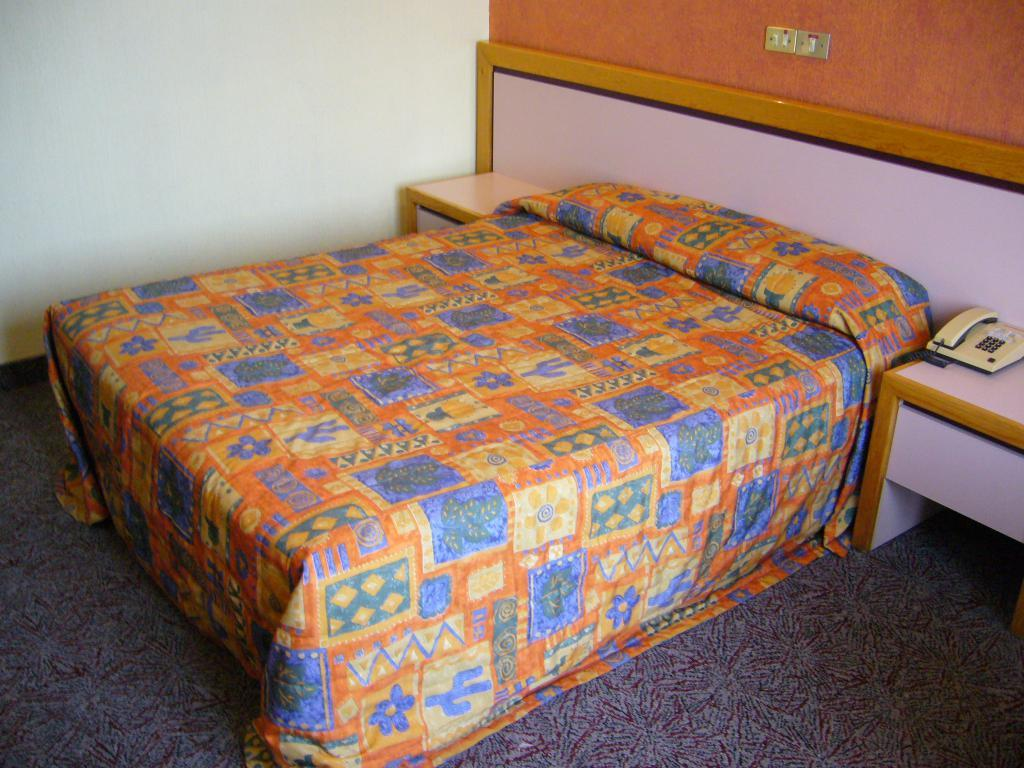What piece of furniture is present in the image? There is a bed in the image. What is covering the bed? The bed has a bed sheet on it. Where is the telephone located in the image? The telephone is on wooden drawers. What is attached to the wall in the image? A switch board is fixed to the wall. How does the branch interact with the telephone in the image? There is no branch present in the image, so it cannot interact with the telephone. 